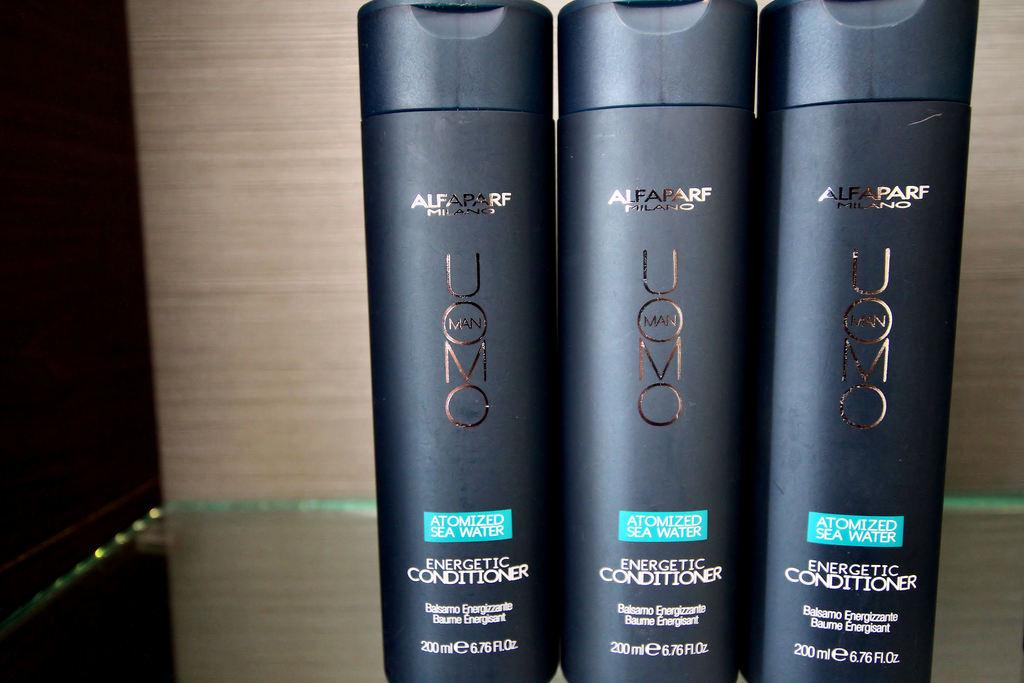<image>
Share a concise interpretation of the image provided. 3 black bottles of 200ml conditioner next to each other 